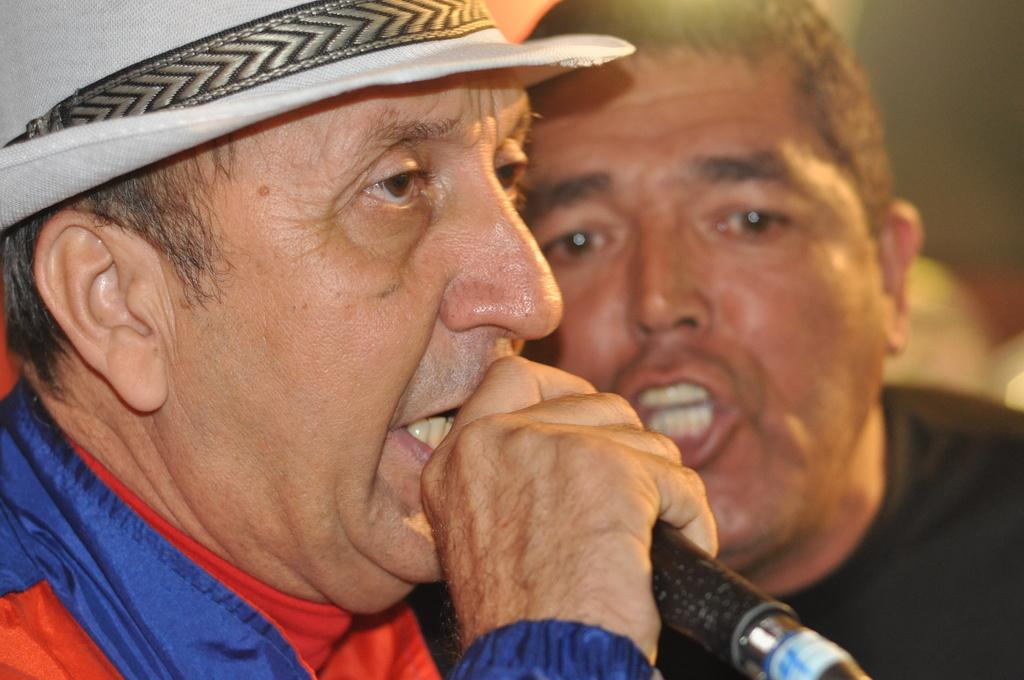How many people are in the image? There are two persons in the image. What is one person doing with their hand? One person is holding a microphone in their hand. What is the person with the microphone doing? The person holding the microphone is talking into it. What type of chicken can be seen flying in the image? There is no chicken present in the image. How many planes are visible in the image? There are no planes visible in the image. 